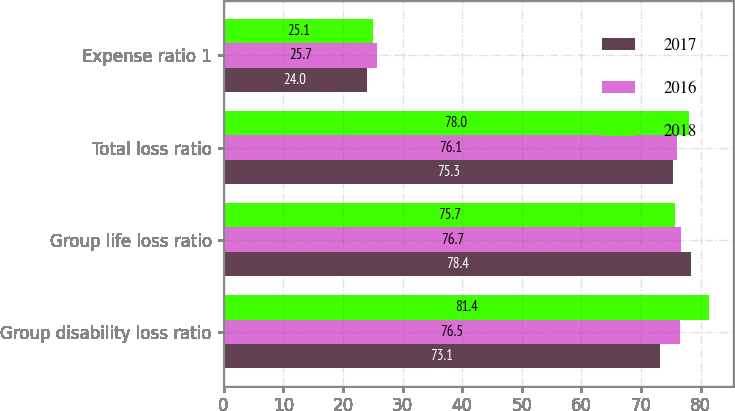Convert chart to OTSL. <chart><loc_0><loc_0><loc_500><loc_500><stacked_bar_chart><ecel><fcel>Group disability loss ratio<fcel>Group life loss ratio<fcel>Total loss ratio<fcel>Expense ratio 1<nl><fcel>2017<fcel>73.1<fcel>78.4<fcel>75.3<fcel>24<nl><fcel>2016<fcel>76.5<fcel>76.7<fcel>76.1<fcel>25.7<nl><fcel>2018<fcel>81.4<fcel>75.7<fcel>78<fcel>25.1<nl></chart> 